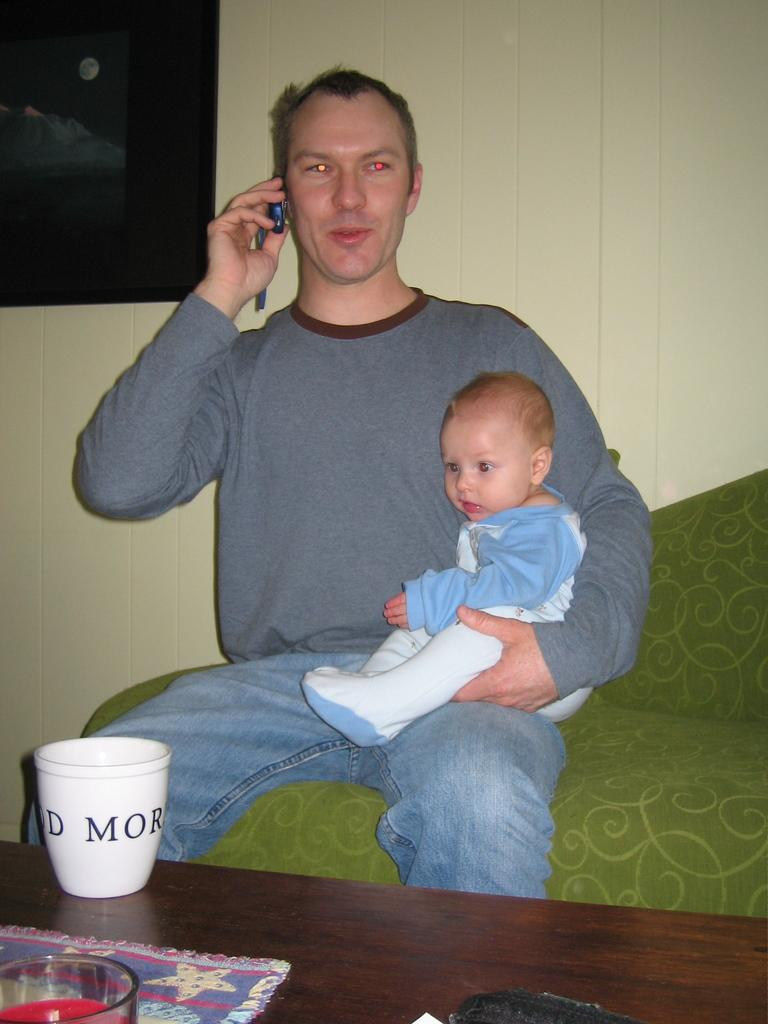What is the man in the image doing? The man is sitting and holding a baby. What is the man also doing while holding the baby? The man is speaking on a mobile phone. What is in front of the man? There is a table in front of the man. What can be seen on the table? There is a glass present on the table. What type of apples can be seen on the man's ear in the image? There are no apples present in the image, and the man's ear is not mentioned in the provided facts. 